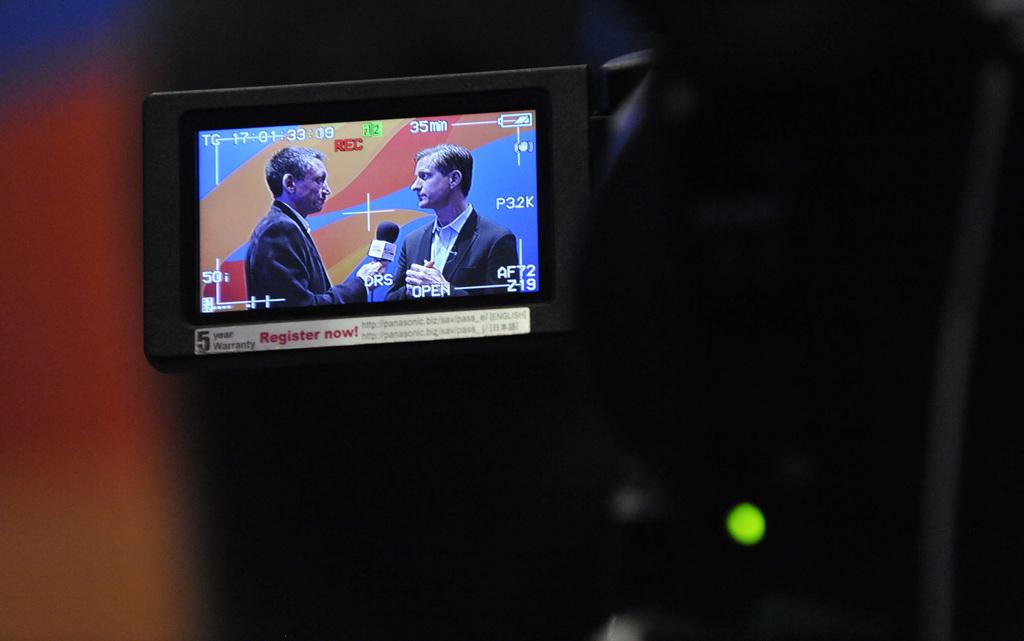Provide a one-sentence caption for the provided image. Someone video recording two people giving an interview for 35 minutes. 